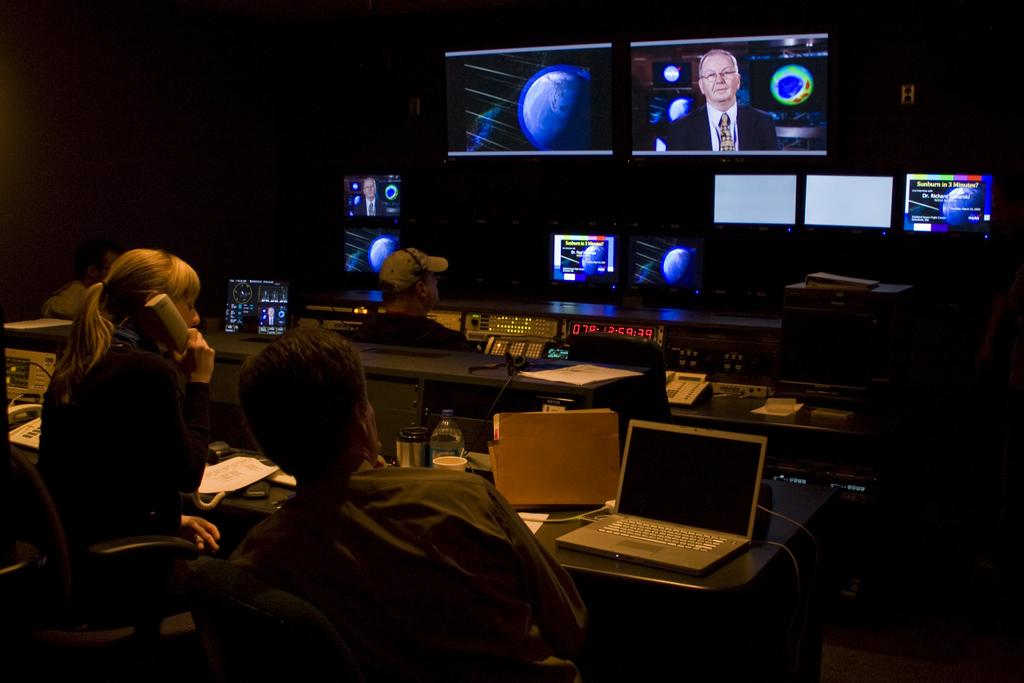Provide a one-sentence caption for the provided image. In a TV control room, workers watch as a report on sunburn plays out. 